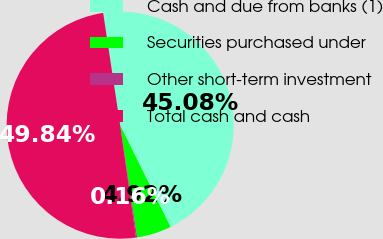<chart> <loc_0><loc_0><loc_500><loc_500><pie_chart><fcel>Cash and due from banks (1)<fcel>Securities purchased under<fcel>Other short-term investment<fcel>Total cash and cash<nl><fcel>45.08%<fcel>4.92%<fcel>0.16%<fcel>49.84%<nl></chart> 